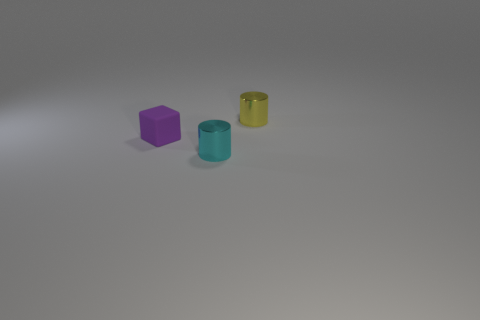Subtract all yellow cylinders. How many cylinders are left? 1 Add 2 tiny objects. How many tiny objects exist? 5 Add 2 small cubes. How many objects exist? 5 Subtract 0 green blocks. How many objects are left? 3 Subtract all cylinders. How many objects are left? 1 Subtract all green cylinders. Subtract all blue balls. How many cylinders are left? 2 Subtract all purple cylinders. How many cyan blocks are left? 0 Subtract all metal things. Subtract all cyan shiny objects. How many objects are left? 0 Add 2 tiny cyan objects. How many tiny cyan objects are left? 3 